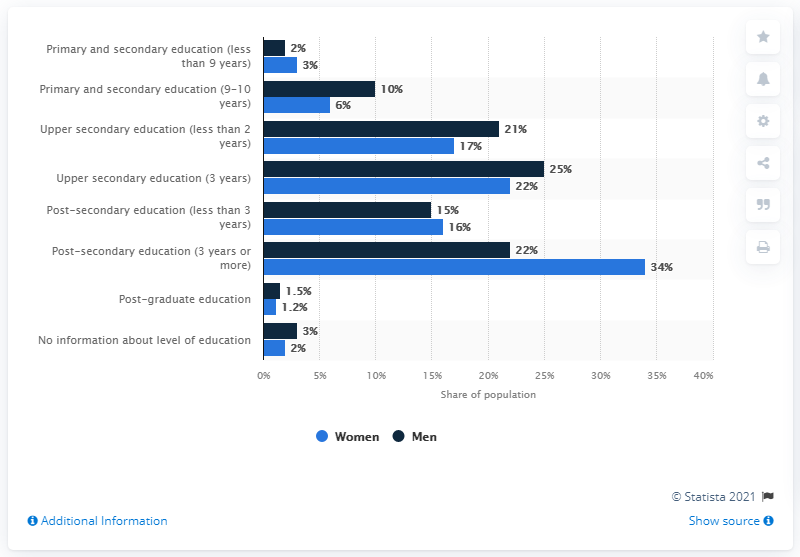Point out several critical features in this image. Post-secondary education (3 years or more) showed the greatest difference in gender compared to other levels of education. The dark blue bar represents men. 